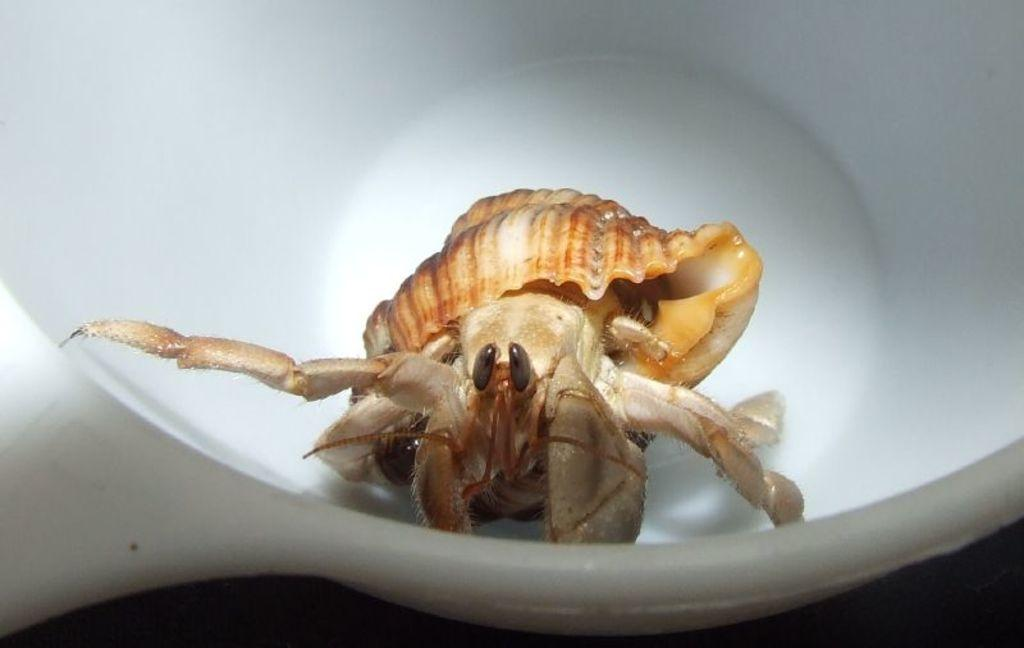What is the main object in the image? There is a white container in the image. What is inside the container? A dungeness crab is present in the container. Are there any other objects in the container besides the crab? Yes, there is a shell in the container. What type of story is being told by the cake in the image? There is no cake present in the image, so no story can be told by a cake. 